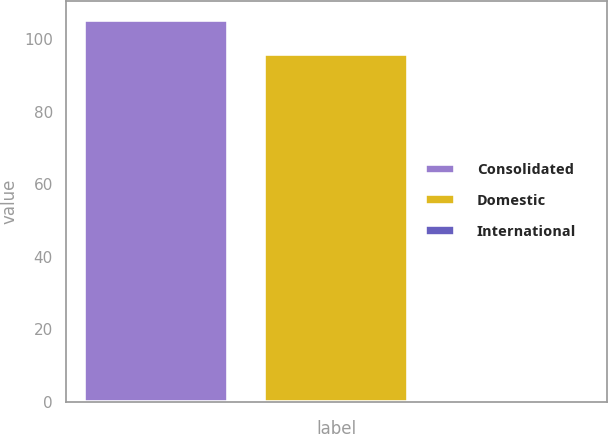Convert chart. <chart><loc_0><loc_0><loc_500><loc_500><bar_chart><fcel>Consolidated<fcel>Domestic<fcel>International<nl><fcel>105.38<fcel>95.8<fcel>0.5<nl></chart> 